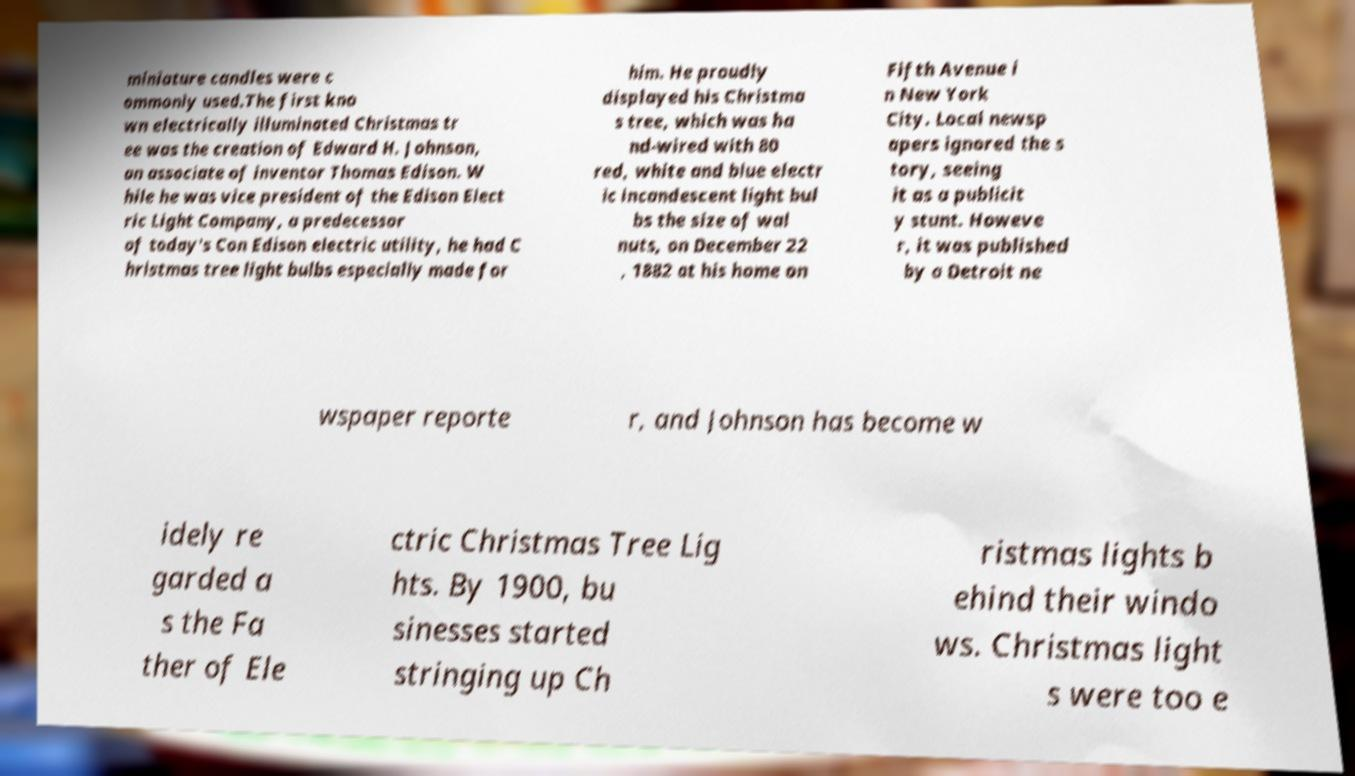Can you read and provide the text displayed in the image?This photo seems to have some interesting text. Can you extract and type it out for me? miniature candles were c ommonly used.The first kno wn electrically illuminated Christmas tr ee was the creation of Edward H. Johnson, an associate of inventor Thomas Edison. W hile he was vice president of the Edison Elect ric Light Company, a predecessor of today's Con Edison electric utility, he had C hristmas tree light bulbs especially made for him. He proudly displayed his Christma s tree, which was ha nd-wired with 80 red, white and blue electr ic incandescent light bul bs the size of wal nuts, on December 22 , 1882 at his home on Fifth Avenue i n New York City. Local newsp apers ignored the s tory, seeing it as a publicit y stunt. Howeve r, it was published by a Detroit ne wspaper reporte r, and Johnson has become w idely re garded a s the Fa ther of Ele ctric Christmas Tree Lig hts. By 1900, bu sinesses started stringing up Ch ristmas lights b ehind their windo ws. Christmas light s were too e 